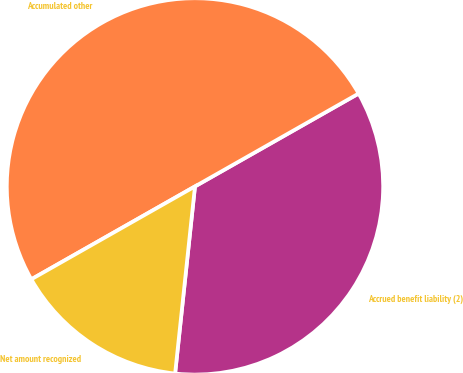Convert chart. <chart><loc_0><loc_0><loc_500><loc_500><pie_chart><fcel>Accrued benefit liability (2)<fcel>Accumulated other<fcel>Net amount recognized<nl><fcel>34.9%<fcel>50.0%<fcel>15.1%<nl></chart> 